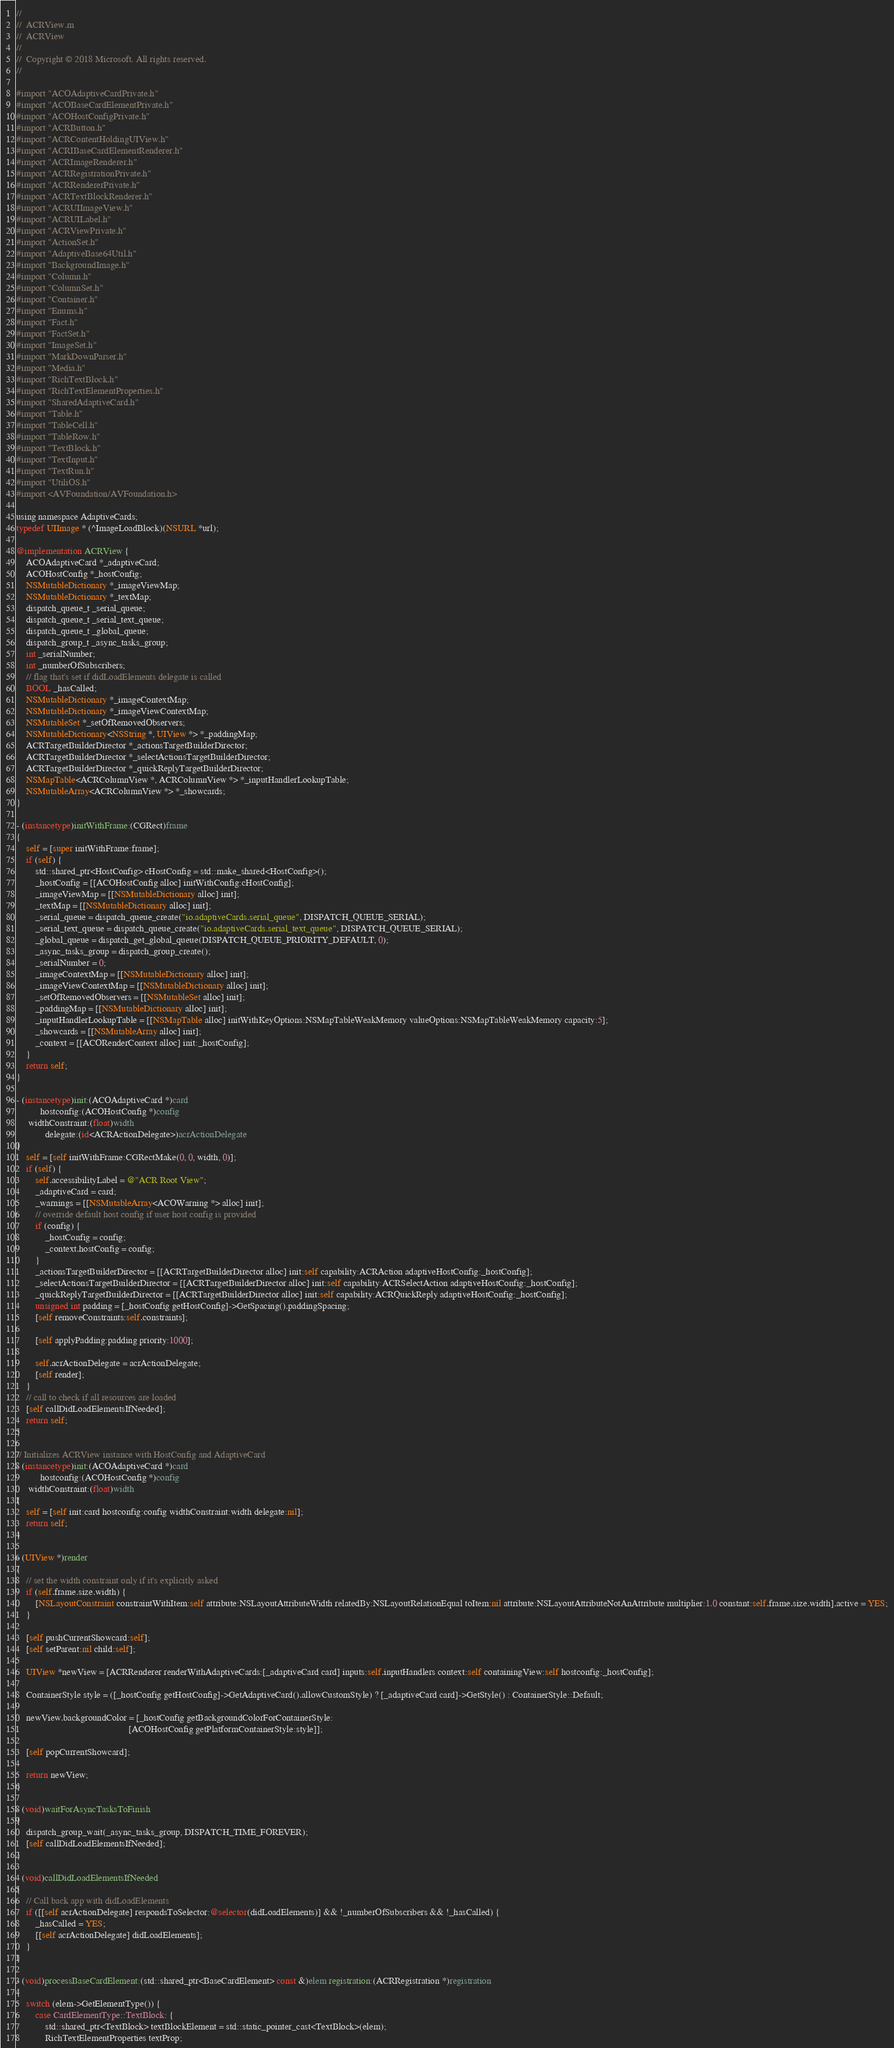Convert code to text. <code><loc_0><loc_0><loc_500><loc_500><_ObjectiveC_>//
//  ACRView.m
//  ACRView
//
//  Copyright © 2018 Microsoft. All rights reserved.
//

#import "ACOAdaptiveCardPrivate.h"
#import "ACOBaseCardElementPrivate.h"
#import "ACOHostConfigPrivate.h"
#import "ACRButton.h"
#import "ACRContentHoldingUIView.h"
#import "ACRIBaseCardElementRenderer.h"
#import "ACRImageRenderer.h"
#import "ACRRegistrationPrivate.h"
#import "ACRRendererPrivate.h"
#import "ACRTextBlockRenderer.h"
#import "ACRUIImageView.h"
#import "ACRUILabel.h"
#import "ACRViewPrivate.h"
#import "ActionSet.h"
#import "AdaptiveBase64Util.h"
#import "BackgroundImage.h"
#import "Column.h"
#import "ColumnSet.h"
#import "Container.h"
#import "Enums.h"
#import "Fact.h"
#import "FactSet.h"
#import "ImageSet.h"
#import "MarkDownParser.h"
#import "Media.h"
#import "RichTextBlock.h"
#import "RichTextElementProperties.h"
#import "SharedAdaptiveCard.h"
#import "Table.h"
#import "TableCell.h"
#import "TableRow.h"
#import "TextBlock.h"
#import "TextInput.h"
#import "TextRun.h"
#import "UtiliOS.h"
#import <AVFoundation/AVFoundation.h>

using namespace AdaptiveCards;
typedef UIImage * (^ImageLoadBlock)(NSURL *url);

@implementation ACRView {
    ACOAdaptiveCard *_adaptiveCard;
    ACOHostConfig *_hostConfig;
    NSMutableDictionary *_imageViewMap;
    NSMutableDictionary *_textMap;
    dispatch_queue_t _serial_queue;
    dispatch_queue_t _serial_text_queue;
    dispatch_queue_t _global_queue;
    dispatch_group_t _async_tasks_group;
    int _serialNumber;
    int _numberOfSubscribers;
    // flag that's set if didLoadElements delegate is called
    BOOL _hasCalled;
    NSMutableDictionary *_imageContextMap;
    NSMutableDictionary *_imageViewContextMap;
    NSMutableSet *_setOfRemovedObservers;
    NSMutableDictionary<NSString *, UIView *> *_paddingMap;
    ACRTargetBuilderDirector *_actionsTargetBuilderDirector;
    ACRTargetBuilderDirector *_selectActionsTargetBuilderDirector;
    ACRTargetBuilderDirector *_quickReplyTargetBuilderDirector;
    NSMapTable<ACRColumnView *, ACRColumnView *> *_inputHandlerLookupTable;
    NSMutableArray<ACRColumnView *> *_showcards;
}

- (instancetype)initWithFrame:(CGRect)frame
{
    self = [super initWithFrame:frame];
    if (self) {
        std::shared_ptr<HostConfig> cHostConfig = std::make_shared<HostConfig>();
        _hostConfig = [[ACOHostConfig alloc] initWithConfig:cHostConfig];
        _imageViewMap = [[NSMutableDictionary alloc] init];
        _textMap = [[NSMutableDictionary alloc] init];
        _serial_queue = dispatch_queue_create("io.adaptiveCards.serial_queue", DISPATCH_QUEUE_SERIAL);
        _serial_text_queue = dispatch_queue_create("io.adaptiveCards.serial_text_queue", DISPATCH_QUEUE_SERIAL);
        _global_queue = dispatch_get_global_queue(DISPATCH_QUEUE_PRIORITY_DEFAULT, 0);
        _async_tasks_group = dispatch_group_create();
        _serialNumber = 0;
        _imageContextMap = [[NSMutableDictionary alloc] init];
        _imageViewContextMap = [[NSMutableDictionary alloc] init];
        _setOfRemovedObservers = [[NSMutableSet alloc] init];
        _paddingMap = [[NSMutableDictionary alloc] init];
        _inputHandlerLookupTable = [[NSMapTable alloc] initWithKeyOptions:NSMapTableWeakMemory valueOptions:NSMapTableWeakMemory capacity:5];
        _showcards = [[NSMutableArray alloc] init];
        _context = [[ACORenderContext alloc] init:_hostConfig];
    }
    return self;
}

- (instancetype)init:(ACOAdaptiveCard *)card
          hostconfig:(ACOHostConfig *)config
     widthConstraint:(float)width
            delegate:(id<ACRActionDelegate>)acrActionDelegate
{
    self = [self initWithFrame:CGRectMake(0, 0, width, 0)];
    if (self) {
        self.accessibilityLabel = @"ACR Root View";
        _adaptiveCard = card;
        _warnings = [[NSMutableArray<ACOWarning *> alloc] init];
        // override default host config if user host config is provided
        if (config) {
            _hostConfig = config;
            _context.hostConfig = config;
        }
        _actionsTargetBuilderDirector = [[ACRTargetBuilderDirector alloc] init:self capability:ACRAction adaptiveHostConfig:_hostConfig];
        _selectActionsTargetBuilderDirector = [[ACRTargetBuilderDirector alloc] init:self capability:ACRSelectAction adaptiveHostConfig:_hostConfig];
        _quickReplyTargetBuilderDirector = [[ACRTargetBuilderDirector alloc] init:self capability:ACRQuickReply adaptiveHostConfig:_hostConfig];
        unsigned int padding = [_hostConfig getHostConfig]->GetSpacing().paddingSpacing;
        [self removeConstraints:self.constraints];

        [self applyPadding:padding priority:1000];

        self.acrActionDelegate = acrActionDelegate;
        [self render];
    }
    // call to check if all resources are loaded
    [self callDidLoadElementsIfNeeded];
    return self;
}

// Initializes ACRView instance with HostConfig and AdaptiveCard
- (instancetype)init:(ACOAdaptiveCard *)card
          hostconfig:(ACOHostConfig *)config
     widthConstraint:(float)width
{
    self = [self init:card hostconfig:config widthConstraint:width delegate:nil];
    return self;
}

- (UIView *)render
{
    // set the width constraint only if it's explicitly asked
    if (self.frame.size.width) {
        [NSLayoutConstraint constraintWithItem:self attribute:NSLayoutAttributeWidth relatedBy:NSLayoutRelationEqual toItem:nil attribute:NSLayoutAttributeNotAnAttribute multiplier:1.0 constant:self.frame.size.width].active = YES;
    }

    [self pushCurrentShowcard:self];
    [self setParent:nil child:self];

    UIView *newView = [ACRRenderer renderWithAdaptiveCards:[_adaptiveCard card] inputs:self.inputHandlers context:self containingView:self hostconfig:_hostConfig];

    ContainerStyle style = ([_hostConfig getHostConfig]->GetAdaptiveCard().allowCustomStyle) ? [_adaptiveCard card]->GetStyle() : ContainerStyle::Default;

    newView.backgroundColor = [_hostConfig getBackgroundColorForContainerStyle:
                                               [ACOHostConfig getPlatformContainerStyle:style]];

    [self popCurrentShowcard];

    return newView;
}

- (void)waitForAsyncTasksToFinish
{
    dispatch_group_wait(_async_tasks_group, DISPATCH_TIME_FOREVER);
    [self callDidLoadElementsIfNeeded];
}

- (void)callDidLoadElementsIfNeeded
{
    // Call back app with didLoadElements
    if ([[self acrActionDelegate] respondsToSelector:@selector(didLoadElements)] && !_numberOfSubscribers && !_hasCalled) {
        _hasCalled = YES;
        [[self acrActionDelegate] didLoadElements];
    }
}

- (void)processBaseCardElement:(std::shared_ptr<BaseCardElement> const &)elem registration:(ACRRegistration *)registration
{
    switch (elem->GetElementType()) {
        case CardElementType::TextBlock: {
            std::shared_ptr<TextBlock> textBlockElement = std::static_pointer_cast<TextBlock>(elem);
            RichTextElementProperties textProp;</code> 